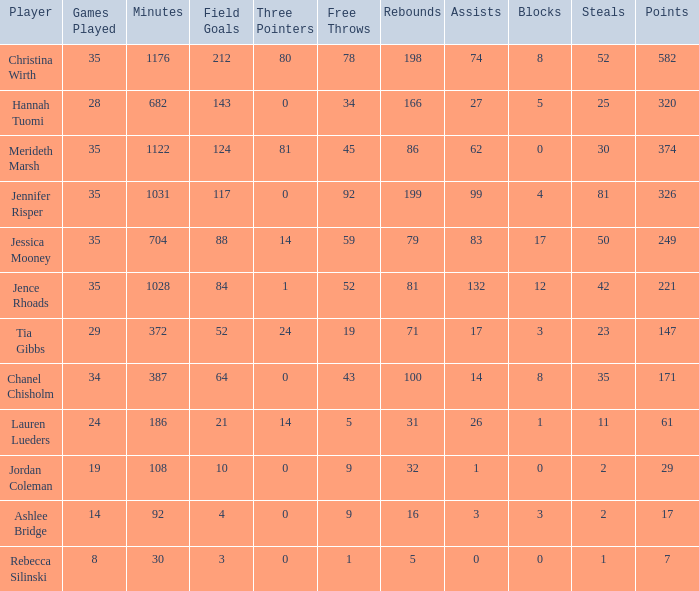How many impediments took place in the game with 198 rebounds? 8.0. 